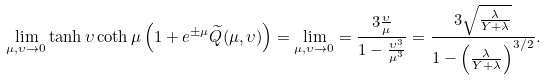Convert formula to latex. <formula><loc_0><loc_0><loc_500><loc_500>\lim _ { \mu , \upsilon \rightarrow 0 } \tanh \upsilon \coth \mu \left ( 1 + e ^ { \pm \mu } \widetilde { Q } ( \mu , \upsilon ) \right ) = \lim _ { \mu , \upsilon \rightarrow 0 } = \frac { 3 \frac { \upsilon } { \mu } } { 1 - \frac { \upsilon ^ { 3 } } { \mu ^ { 3 } } } = \frac { 3 \sqrt { \frac { \lambda } { Y + \lambda } } } { 1 - \left ( \frac { \lambda } { Y + \lambda } \right ) ^ { 3 / 2 } } .</formula> 